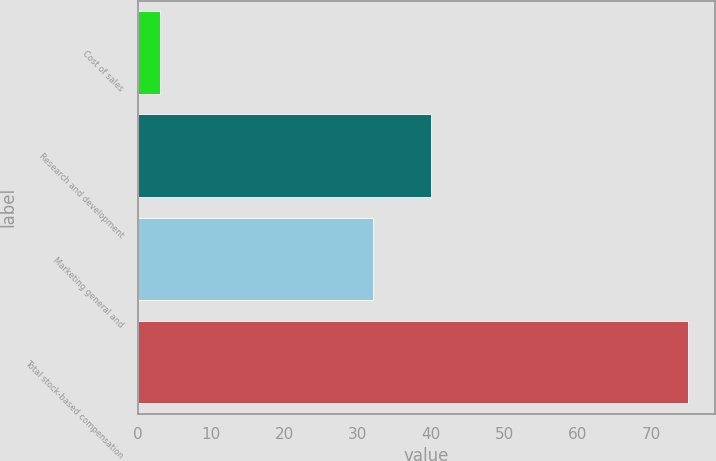Convert chart to OTSL. <chart><loc_0><loc_0><loc_500><loc_500><bar_chart><fcel>Cost of sales<fcel>Research and development<fcel>Marketing general and<fcel>Total stock-based compensation<nl><fcel>3<fcel>40<fcel>32<fcel>75<nl></chart> 